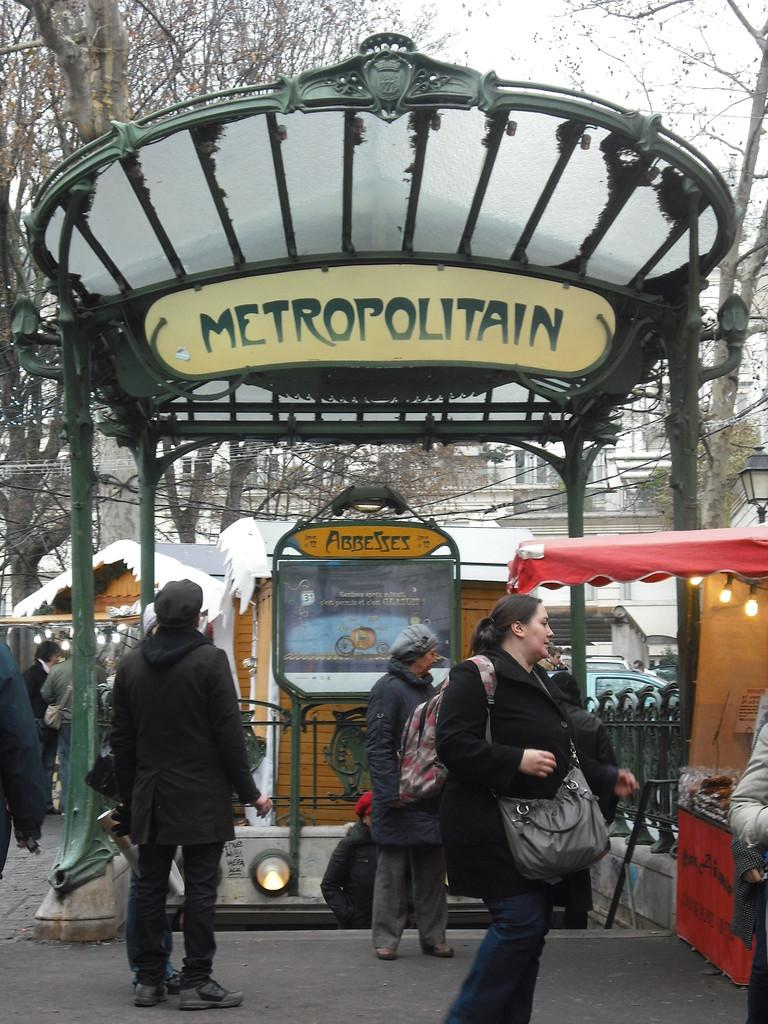Who or what can be seen in the image? There are people in the image. What type of structure is present in the image? There is a shed in the image. What is located on the right side of the image? There is a tent on the right side of the image. What can be seen near the tent? There are lights visible near the tent. What can be seen in the distance in the image? There are cottages, trees, and buildings in the background of the image. What is visible in the sky in the image? The sky is visible in the background of the image. What type of dirt is being used to change the stick's color in the image? There is no dirt or stick present in the image, so this question cannot be answered. 